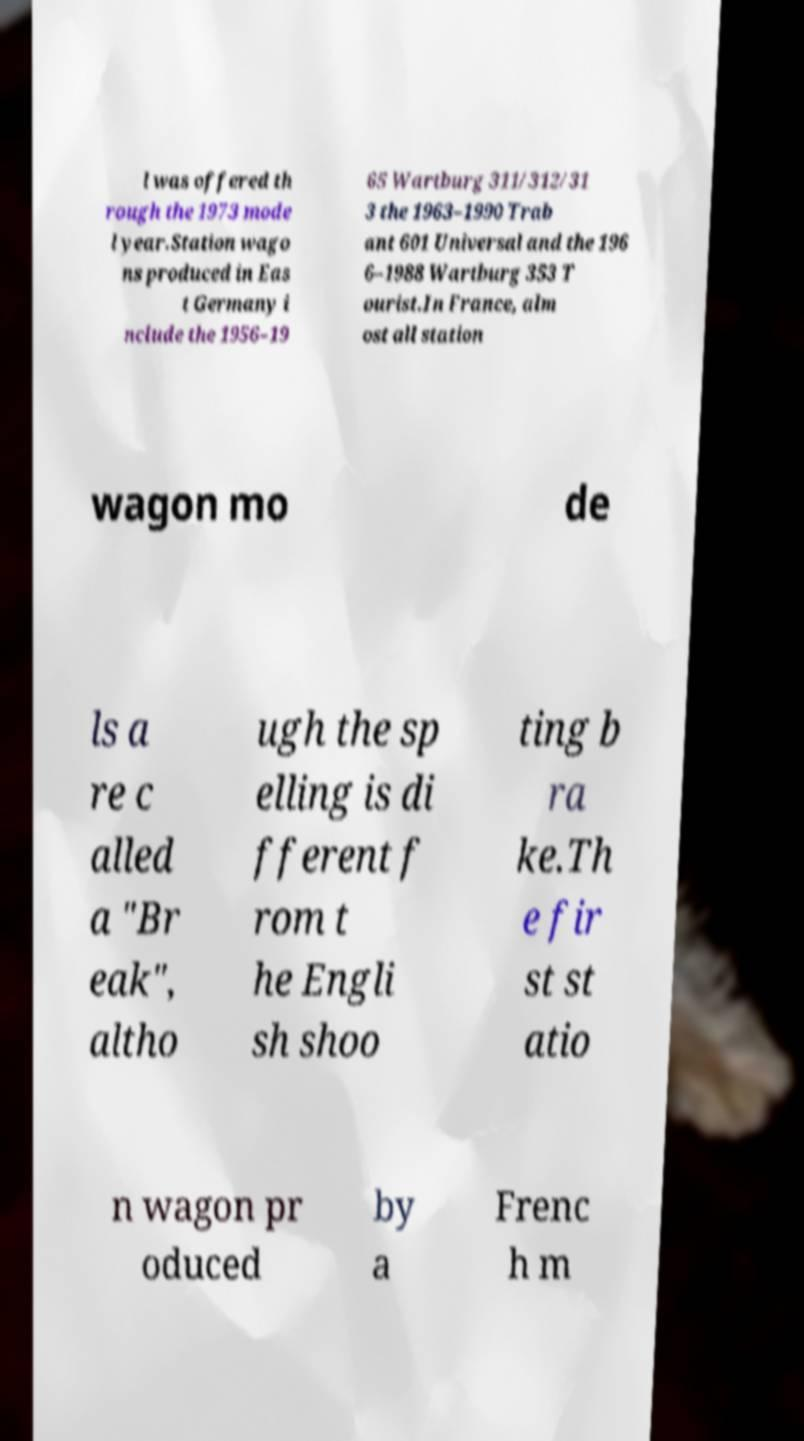Could you extract and type out the text from this image? l was offered th rough the 1973 mode l year.Station wago ns produced in Eas t Germany i nclude the 1956–19 65 Wartburg 311/312/31 3 the 1963–1990 Trab ant 601 Universal and the 196 6–1988 Wartburg 353 T ourist.In France, alm ost all station wagon mo de ls a re c alled a "Br eak", altho ugh the sp elling is di fferent f rom t he Engli sh shoo ting b ra ke.Th e fir st st atio n wagon pr oduced by a Frenc h m 